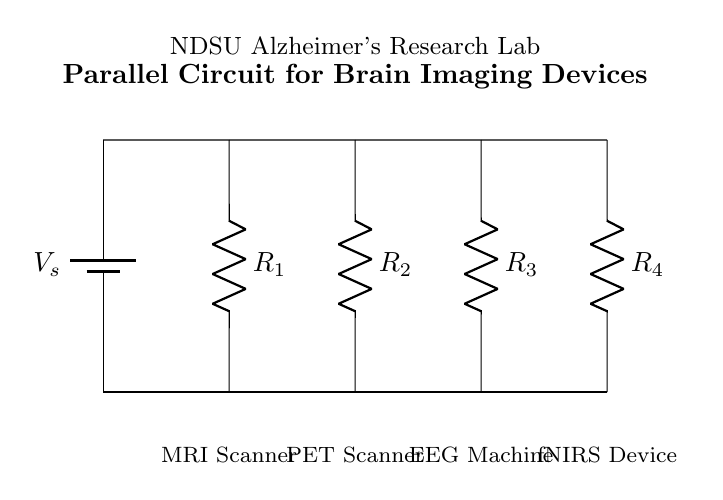What is the power supply in this circuit? The circuit shows a battery labeled as V_s, which serves as the power supply.
Answer: V_s How many devices are powered by this parallel circuit? The circuit features four devices: an MRI Scanner, PET Scanner, EEG Machine, and fNIRS Device, all connected in parallel.
Answer: Four devices What is the function of component R_1? R_1 is a resistor in the circuit acting as a current-limiting element for the MRI Scanner.
Answer: Current-limiting element Which device is connected to resistor R_3? R_3 is connected to the EEG Machine, as indicated by the labeling in the diagram.
Answer: EEG Machine What type of circuit is represented here? This circuit is a parallel circuit, as all components are connected alongside each other to the same voltage source.
Answer: Parallel If R_2 has a resistance of 10 ohms, what happens to the voltage across it? In a parallel circuit, the voltage across each component is the same as the power supply voltage, so the voltage across R_2 is equal to V_s.
Answer: Equal to V_s 